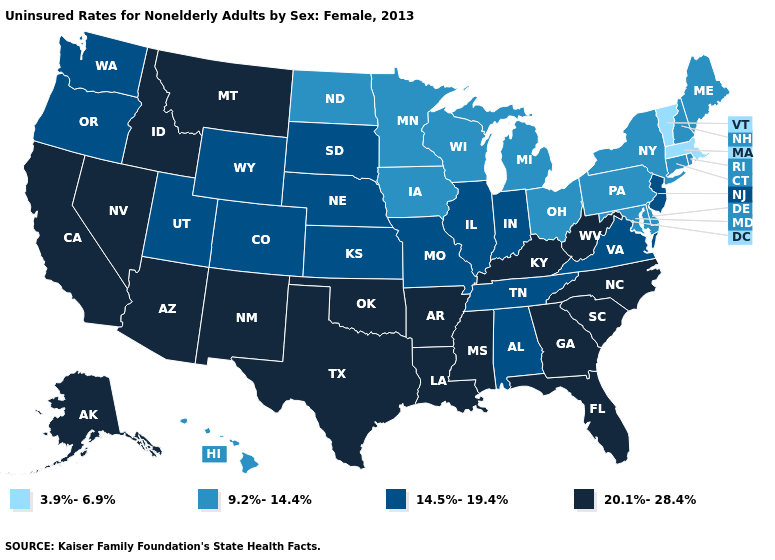Among the states that border North Dakota , which have the lowest value?
Answer briefly. Minnesota. Among the states that border Michigan , which have the lowest value?
Answer briefly. Ohio, Wisconsin. Which states have the lowest value in the South?
Short answer required. Delaware, Maryland. Which states have the lowest value in the USA?
Answer briefly. Massachusetts, Vermont. Which states have the lowest value in the South?
Keep it brief. Delaware, Maryland. Name the states that have a value in the range 9.2%-14.4%?
Short answer required. Connecticut, Delaware, Hawaii, Iowa, Maine, Maryland, Michigan, Minnesota, New Hampshire, New York, North Dakota, Ohio, Pennsylvania, Rhode Island, Wisconsin. Name the states that have a value in the range 20.1%-28.4%?
Be succinct. Alaska, Arizona, Arkansas, California, Florida, Georgia, Idaho, Kentucky, Louisiana, Mississippi, Montana, Nevada, New Mexico, North Carolina, Oklahoma, South Carolina, Texas, West Virginia. What is the value of Texas?
Be succinct. 20.1%-28.4%. Does Iowa have the same value as California?
Be succinct. No. Does New Jersey have the highest value in the Northeast?
Short answer required. Yes. Does Wisconsin have a lower value than Vermont?
Quick response, please. No. Which states have the lowest value in the South?
Short answer required. Delaware, Maryland. What is the value of Nevada?
Answer briefly. 20.1%-28.4%. Name the states that have a value in the range 3.9%-6.9%?
Give a very brief answer. Massachusetts, Vermont. 